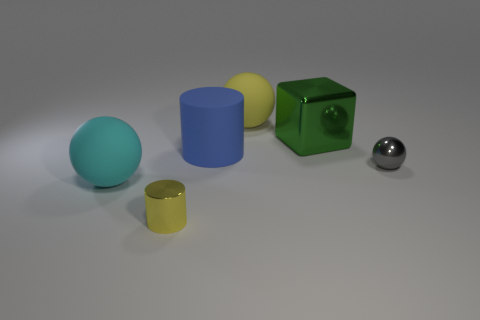Subtract all big spheres. How many spheres are left? 1 Add 4 big cylinders. How many objects exist? 10 Subtract 2 cylinders. How many cylinders are left? 0 Subtract all yellow cylinders. How many cylinders are left? 1 Subtract all cylinders. How many objects are left? 4 Subtract all gray shiny balls. Subtract all large cyan things. How many objects are left? 4 Add 3 small metallic cylinders. How many small metallic cylinders are left? 4 Add 3 large green metallic blocks. How many large green metallic blocks exist? 4 Subtract 0 purple cubes. How many objects are left? 6 Subtract all blue cylinders. Subtract all brown spheres. How many cylinders are left? 1 